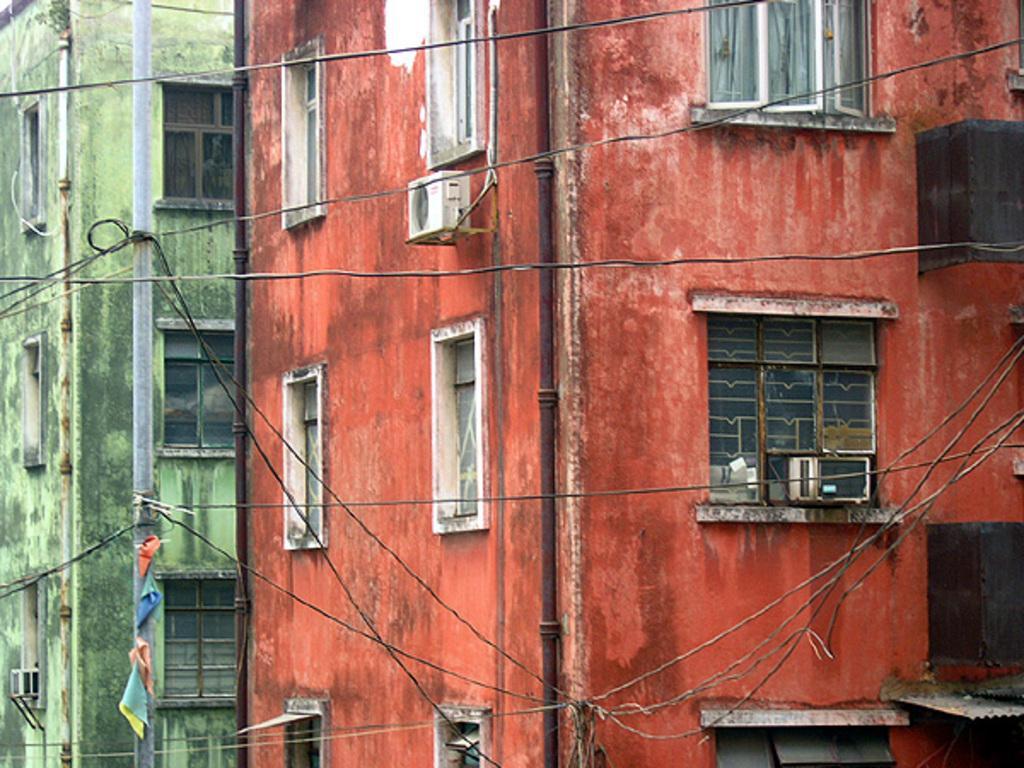Describe this image in one or two sentences. In the foreground of the picture there are cables. In the background there are buildings, windows, pipes, air conditioners and a pole. 